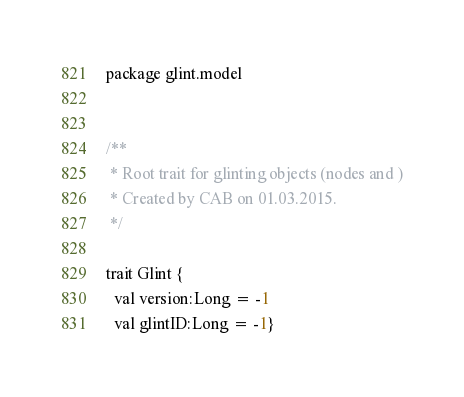<code> <loc_0><loc_0><loc_500><loc_500><_Scala_>package glint.model


/**
 * Root trait for glinting objects (nodes and )
 * Created by CAB on 01.03.2015.
 */

trait Glint {
  val version:Long = -1
  val glintID:Long = -1}
</code> 